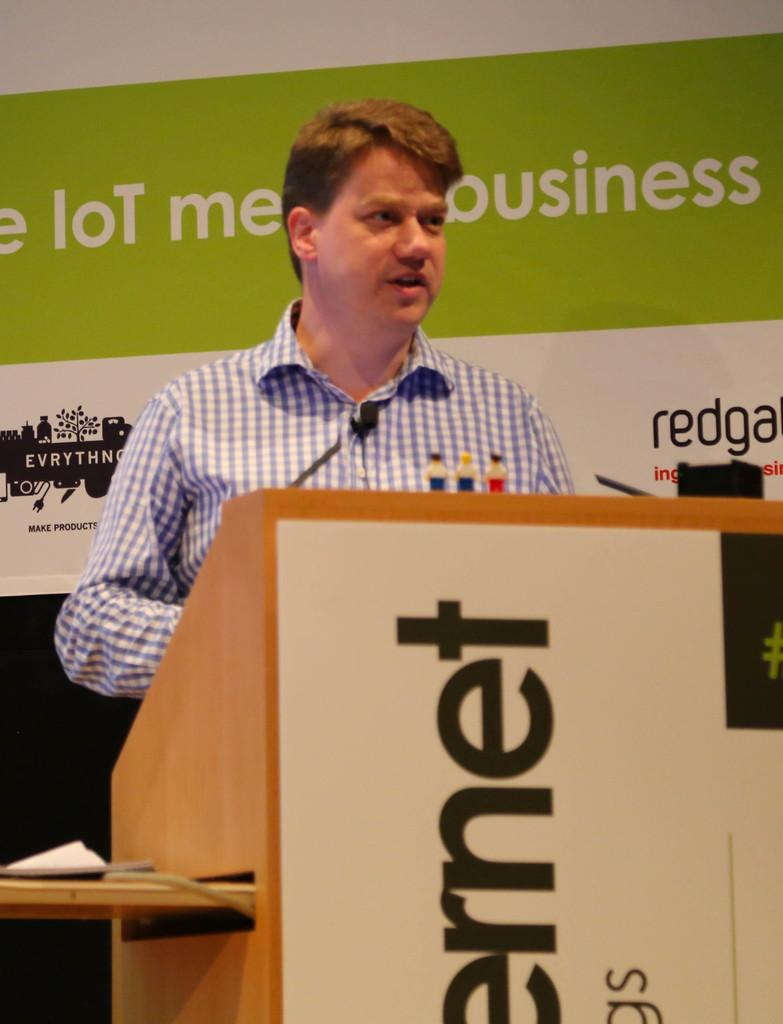<image>
Create a compact narrative representing the image presented. Man giving a speech in front of a podium that says "rnet". 